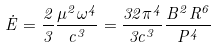Convert formula to latex. <formula><loc_0><loc_0><loc_500><loc_500>\dot { E } = \frac { 2 } { 3 } \frac { \mu ^ { 2 } \omega ^ { 4 } } { c ^ { 3 } } = \frac { 3 2 \pi ^ { 4 } } { 3 c ^ { 3 } } \frac { B ^ { 2 } R ^ { 6 } } { P ^ { 4 } }</formula> 